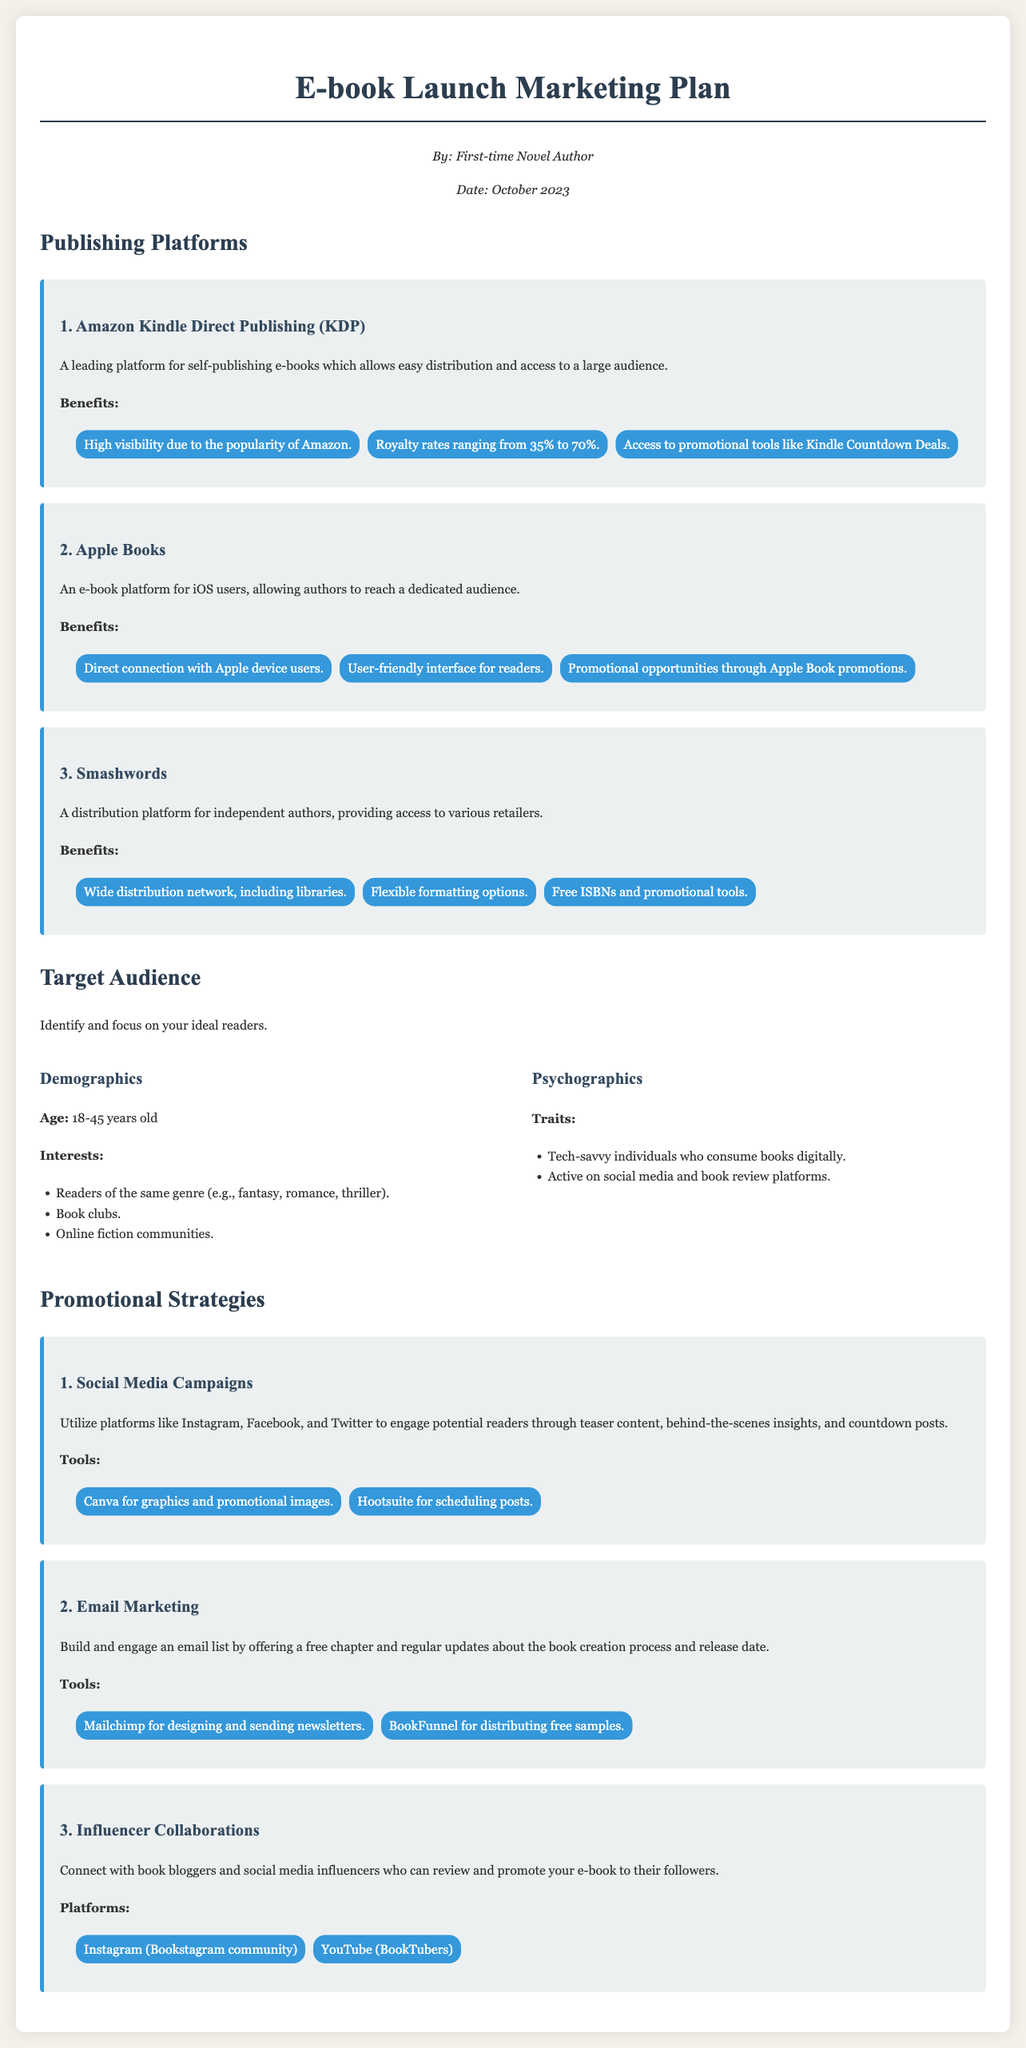what is the title of the document? The title is prominently displayed at the top of the document, which is "E-book Launch Marketing Plan."
Answer: E-book Launch Marketing Plan who is the author of the document? The author is mentioned in the author information section, stating "First-time Novel Author."
Answer: First-time Novel Author which platform offers royalty rates ranging from 35% to 70%? The document lists the benefits of different platforms, and Amazon KDP is specified to have this royalty rate.
Answer: Amazon Kindle Direct Publishing (KDP) what is the age range of the target audience? The document specifies the target audience's age range in the demographics section as "18-45 years old."
Answer: 18-45 years old name one tool recommended for social media campaigns. The document lists tools for promotional strategies and mentions Canva for graphics and promotional images.
Answer: Canva how many platforms are listed in the publishing section? The document details three platforms for publishing in the respective section.
Answer: Three what is a promotional strategy that involves engaging book bloggers? The document specifies that "Influencer Collaborations" is a promotional strategy involving book bloggers.
Answer: Influencer Collaborations which platform is dedicated to iOS users? The document describes Apple Books as an e-book platform specifically for iOS users.
Answer: Apple Books what type of email marketing tool is mentioned? One of the tools mentioned for email marketing is Mailchimp, which helps design and send newsletters.
Answer: Mailchimp 